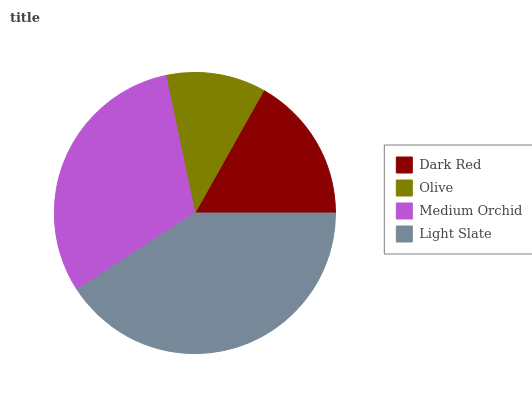Is Olive the minimum?
Answer yes or no. Yes. Is Light Slate the maximum?
Answer yes or no. Yes. Is Medium Orchid the minimum?
Answer yes or no. No. Is Medium Orchid the maximum?
Answer yes or no. No. Is Medium Orchid greater than Olive?
Answer yes or no. Yes. Is Olive less than Medium Orchid?
Answer yes or no. Yes. Is Olive greater than Medium Orchid?
Answer yes or no. No. Is Medium Orchid less than Olive?
Answer yes or no. No. Is Medium Orchid the high median?
Answer yes or no. Yes. Is Dark Red the low median?
Answer yes or no. Yes. Is Light Slate the high median?
Answer yes or no. No. Is Medium Orchid the low median?
Answer yes or no. No. 